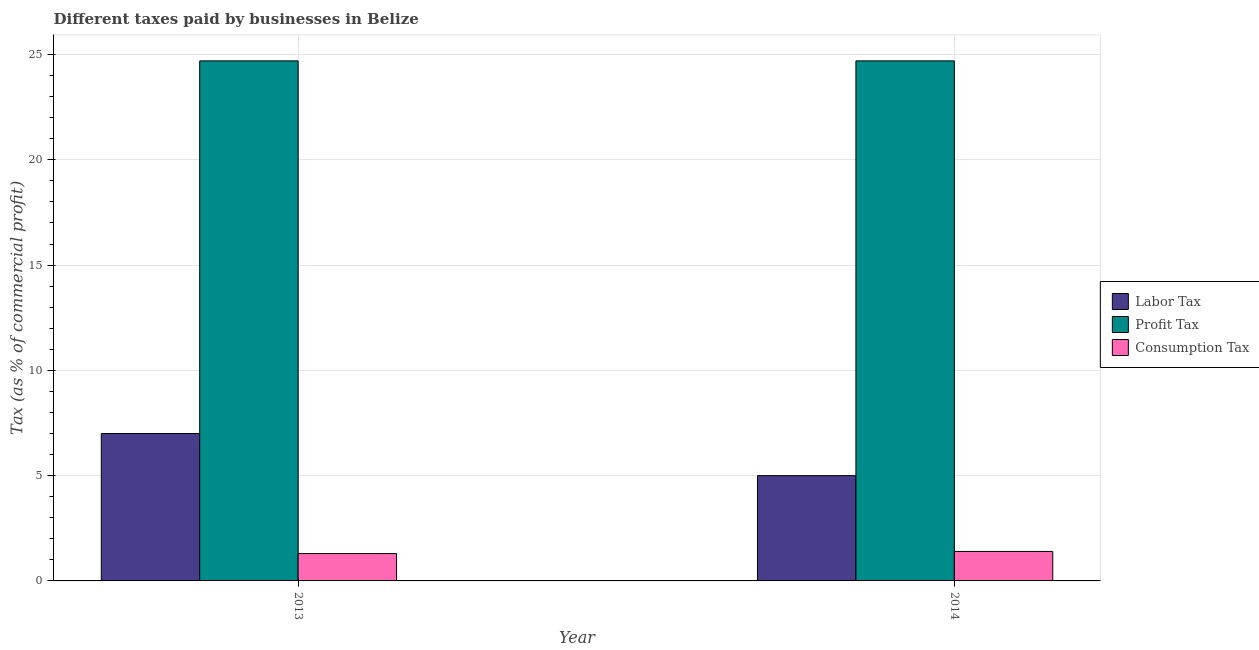How many different coloured bars are there?
Your response must be concise. 3. Are the number of bars per tick equal to the number of legend labels?
Your answer should be compact. Yes. In how many cases, is the number of bars for a given year not equal to the number of legend labels?
Provide a short and direct response. 0. What is the percentage of consumption tax in 2013?
Provide a short and direct response. 1.3. Across all years, what is the maximum percentage of labor tax?
Provide a short and direct response. 7. Across all years, what is the minimum percentage of profit tax?
Keep it short and to the point. 24.7. In which year was the percentage of labor tax minimum?
Make the answer very short. 2014. What is the total percentage of profit tax in the graph?
Provide a succinct answer. 49.4. What is the difference between the percentage of labor tax in 2013 and that in 2014?
Your answer should be very brief. 2. What is the difference between the percentage of profit tax in 2013 and the percentage of labor tax in 2014?
Keep it short and to the point. 0. What is the average percentage of profit tax per year?
Keep it short and to the point. 24.7. In how many years, is the percentage of consumption tax greater than 21 %?
Provide a short and direct response. 0. What is the ratio of the percentage of consumption tax in 2013 to that in 2014?
Provide a succinct answer. 0.93. Is the percentage of profit tax in 2013 less than that in 2014?
Your answer should be compact. No. In how many years, is the percentage of profit tax greater than the average percentage of profit tax taken over all years?
Make the answer very short. 0. What does the 2nd bar from the left in 2013 represents?
Offer a terse response. Profit Tax. What does the 3rd bar from the right in 2014 represents?
Your answer should be compact. Labor Tax. How many bars are there?
Give a very brief answer. 6. Are all the bars in the graph horizontal?
Your answer should be very brief. No. What is the difference between two consecutive major ticks on the Y-axis?
Make the answer very short. 5. Does the graph contain any zero values?
Provide a short and direct response. No. Where does the legend appear in the graph?
Offer a terse response. Center right. How are the legend labels stacked?
Offer a terse response. Vertical. What is the title of the graph?
Offer a very short reply. Different taxes paid by businesses in Belize. What is the label or title of the X-axis?
Your answer should be compact. Year. What is the label or title of the Y-axis?
Provide a succinct answer. Tax (as % of commercial profit). What is the Tax (as % of commercial profit) of Labor Tax in 2013?
Your answer should be very brief. 7. What is the Tax (as % of commercial profit) in Profit Tax in 2013?
Your answer should be compact. 24.7. What is the Tax (as % of commercial profit) of Consumption Tax in 2013?
Your answer should be compact. 1.3. What is the Tax (as % of commercial profit) of Profit Tax in 2014?
Your answer should be compact. 24.7. What is the Tax (as % of commercial profit) of Consumption Tax in 2014?
Provide a short and direct response. 1.4. Across all years, what is the maximum Tax (as % of commercial profit) of Labor Tax?
Your response must be concise. 7. Across all years, what is the maximum Tax (as % of commercial profit) in Profit Tax?
Ensure brevity in your answer.  24.7. Across all years, what is the minimum Tax (as % of commercial profit) of Profit Tax?
Your answer should be very brief. 24.7. Across all years, what is the minimum Tax (as % of commercial profit) of Consumption Tax?
Ensure brevity in your answer.  1.3. What is the total Tax (as % of commercial profit) in Profit Tax in the graph?
Offer a very short reply. 49.4. What is the difference between the Tax (as % of commercial profit) in Labor Tax in 2013 and that in 2014?
Keep it short and to the point. 2. What is the difference between the Tax (as % of commercial profit) of Profit Tax in 2013 and that in 2014?
Offer a very short reply. 0. What is the difference between the Tax (as % of commercial profit) in Labor Tax in 2013 and the Tax (as % of commercial profit) in Profit Tax in 2014?
Ensure brevity in your answer.  -17.7. What is the difference between the Tax (as % of commercial profit) of Labor Tax in 2013 and the Tax (as % of commercial profit) of Consumption Tax in 2014?
Your response must be concise. 5.6. What is the difference between the Tax (as % of commercial profit) in Profit Tax in 2013 and the Tax (as % of commercial profit) in Consumption Tax in 2014?
Provide a short and direct response. 23.3. What is the average Tax (as % of commercial profit) in Labor Tax per year?
Offer a very short reply. 6. What is the average Tax (as % of commercial profit) of Profit Tax per year?
Make the answer very short. 24.7. What is the average Tax (as % of commercial profit) in Consumption Tax per year?
Your answer should be very brief. 1.35. In the year 2013, what is the difference between the Tax (as % of commercial profit) in Labor Tax and Tax (as % of commercial profit) in Profit Tax?
Ensure brevity in your answer.  -17.7. In the year 2013, what is the difference between the Tax (as % of commercial profit) of Profit Tax and Tax (as % of commercial profit) of Consumption Tax?
Provide a short and direct response. 23.4. In the year 2014, what is the difference between the Tax (as % of commercial profit) of Labor Tax and Tax (as % of commercial profit) of Profit Tax?
Make the answer very short. -19.7. In the year 2014, what is the difference between the Tax (as % of commercial profit) in Profit Tax and Tax (as % of commercial profit) in Consumption Tax?
Offer a terse response. 23.3. What is the ratio of the Tax (as % of commercial profit) in Profit Tax in 2013 to that in 2014?
Make the answer very short. 1. What is the ratio of the Tax (as % of commercial profit) of Consumption Tax in 2013 to that in 2014?
Provide a succinct answer. 0.93. What is the difference between the highest and the second highest Tax (as % of commercial profit) of Profit Tax?
Ensure brevity in your answer.  0. What is the difference between the highest and the second highest Tax (as % of commercial profit) in Consumption Tax?
Give a very brief answer. 0.1. What is the difference between the highest and the lowest Tax (as % of commercial profit) of Profit Tax?
Offer a very short reply. 0. 